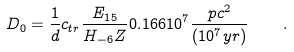<formula> <loc_0><loc_0><loc_500><loc_500>D _ { 0 } = \frac { 1 } { d } c _ { t r } \frac { E _ { 1 5 } } { H _ { - 6 } Z } 0 . 1 6 6 1 0 ^ { 7 } \frac { p c ^ { 2 } } { ( 1 0 ^ { 7 } y r ) } \quad .</formula> 